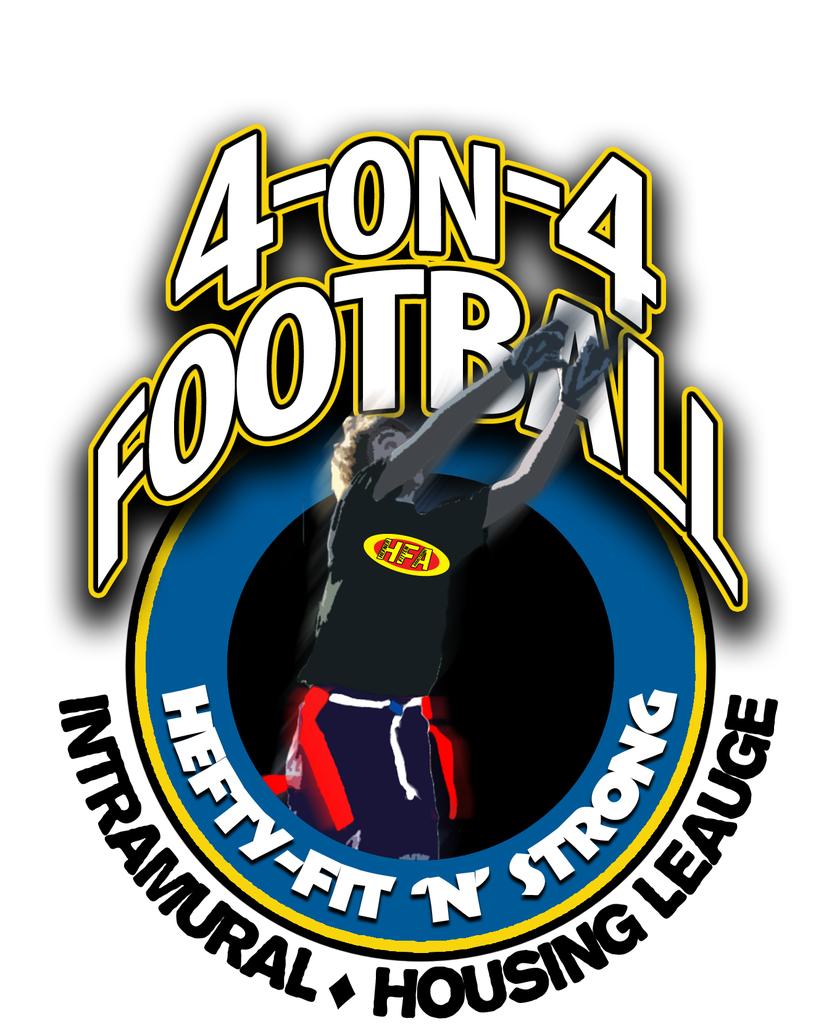What sport is being advertised here?
Ensure brevity in your answer.  Football. What is the name of the organization?
Provide a succinct answer. 4-on-4 football. 